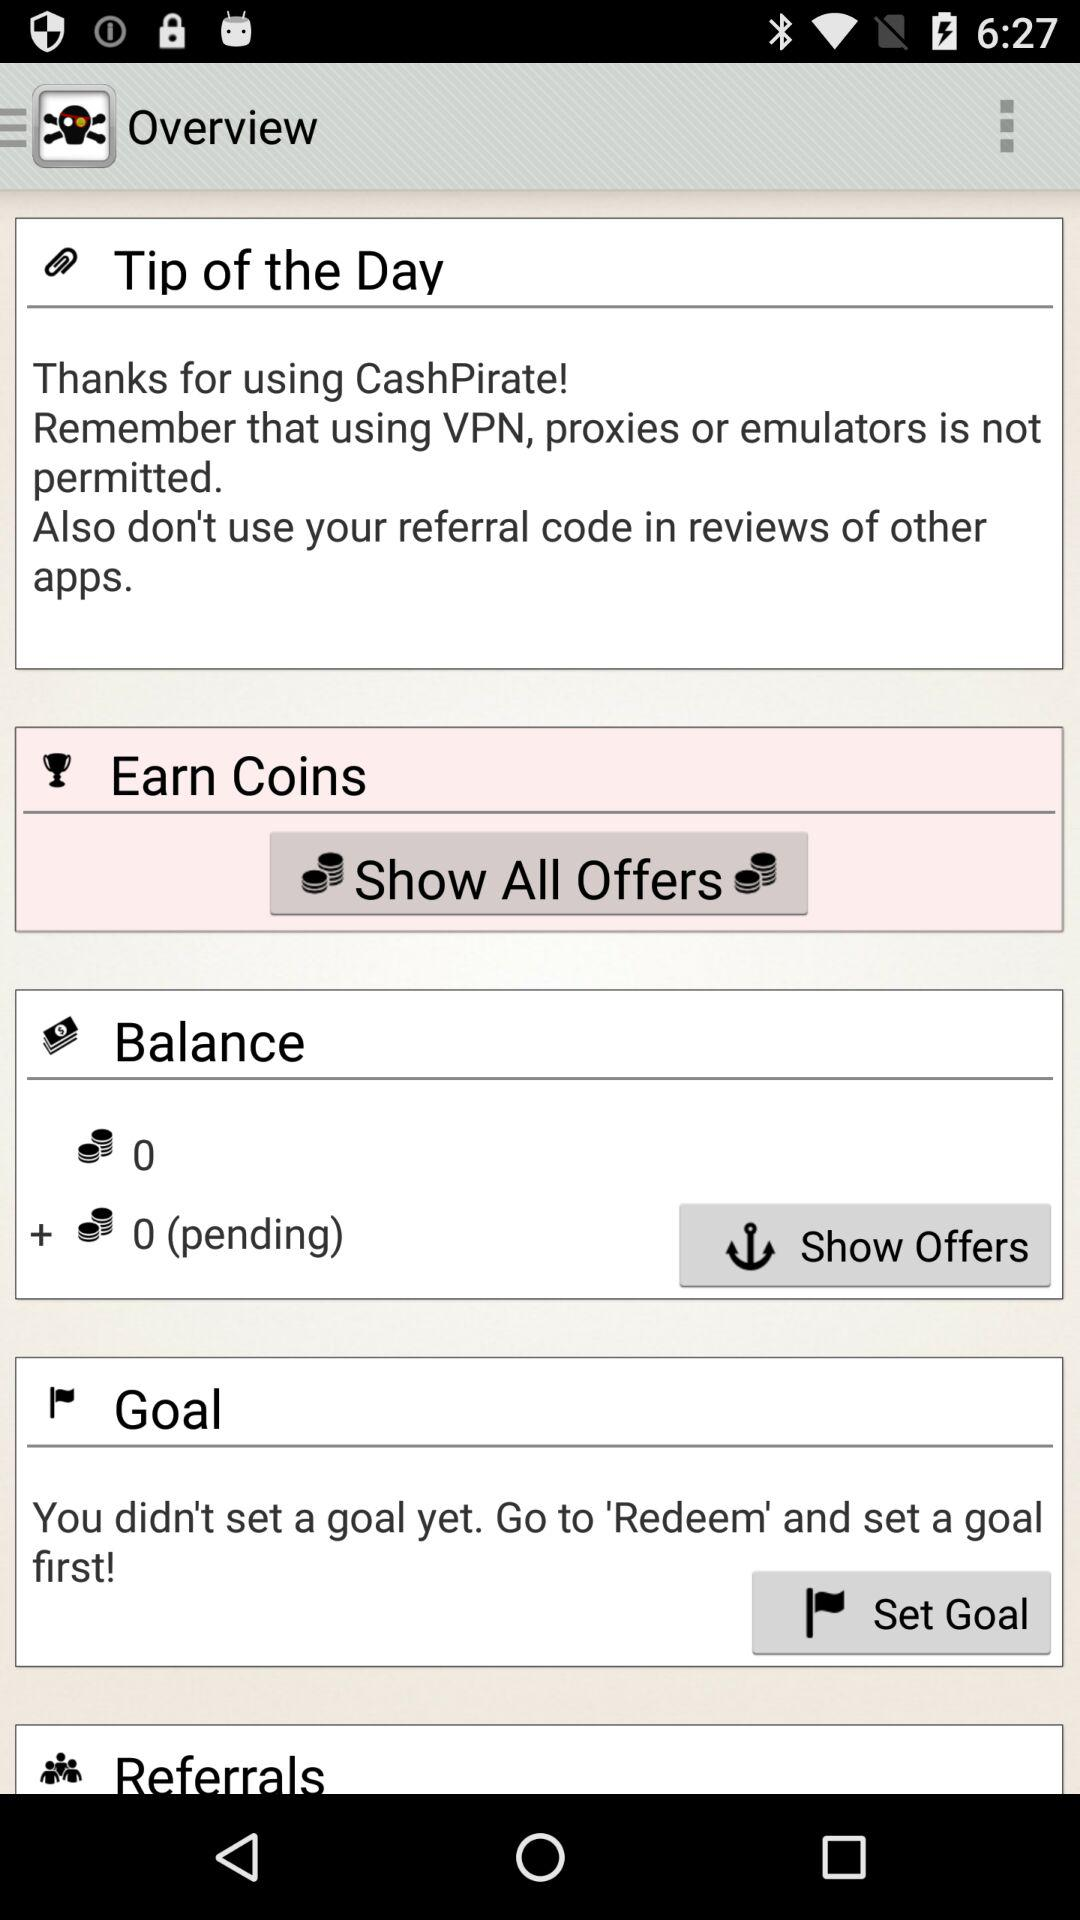What is the amount of the pending balance? The amount is 0. 